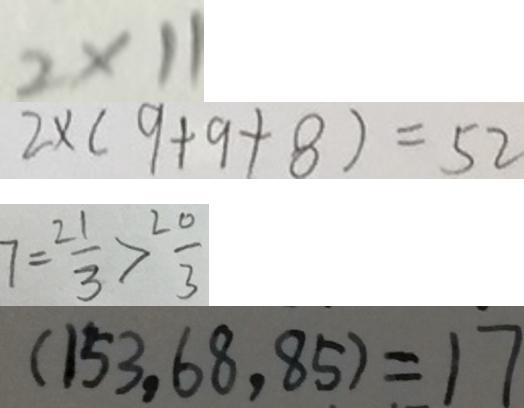Convert formula to latex. <formula><loc_0><loc_0><loc_500><loc_500>2 \times 1 1 
 2 \times ( 9 + 9 + 8 ) = 5 2 
 7 = \frac { 2 1 } { 3 } > \frac { 2 0 } { 3 } 
 ( 1 5 3 , 6 8 , 8 5 ) = 1 7</formula> 